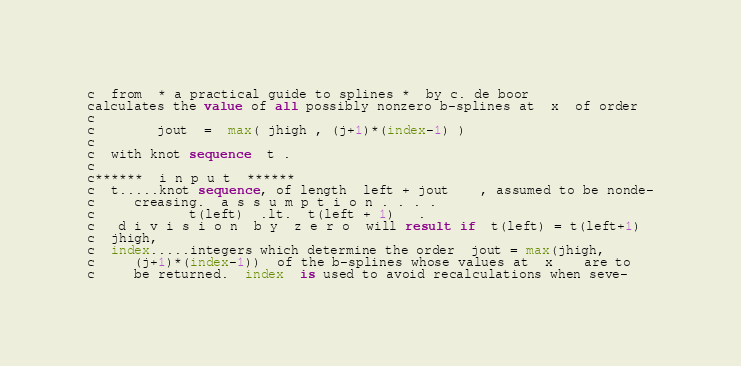<code> <loc_0><loc_0><loc_500><loc_500><_FORTRAN_>c  from  * a practical guide to splines *  by c. de boor
calculates the value of all possibly nonzero b-splines at  x  of order
c
c		jout  =  max( jhigh , (j+1)*(index-1) )
c
c  with knot sequence  t .
c
c******  i n p u t  ******
c  t.....knot sequence, of length  left + jout	, assumed to be nonde-
c	 creasing.  a s s u m p t i o n . . . .
c			t(left)  .lt.  t(left + 1)   .
c   d i v i s i o n  b y  z e r o  will result if  t(left) = t(left+1)
c  jhigh,
c  index.....integers which determine the order  jout = max(jhigh,
c	 (j+1)*(index-1))  of the b-splines whose values at  x	are to
c	 be returned.  index  is used to avoid recalculations when seve-</code> 